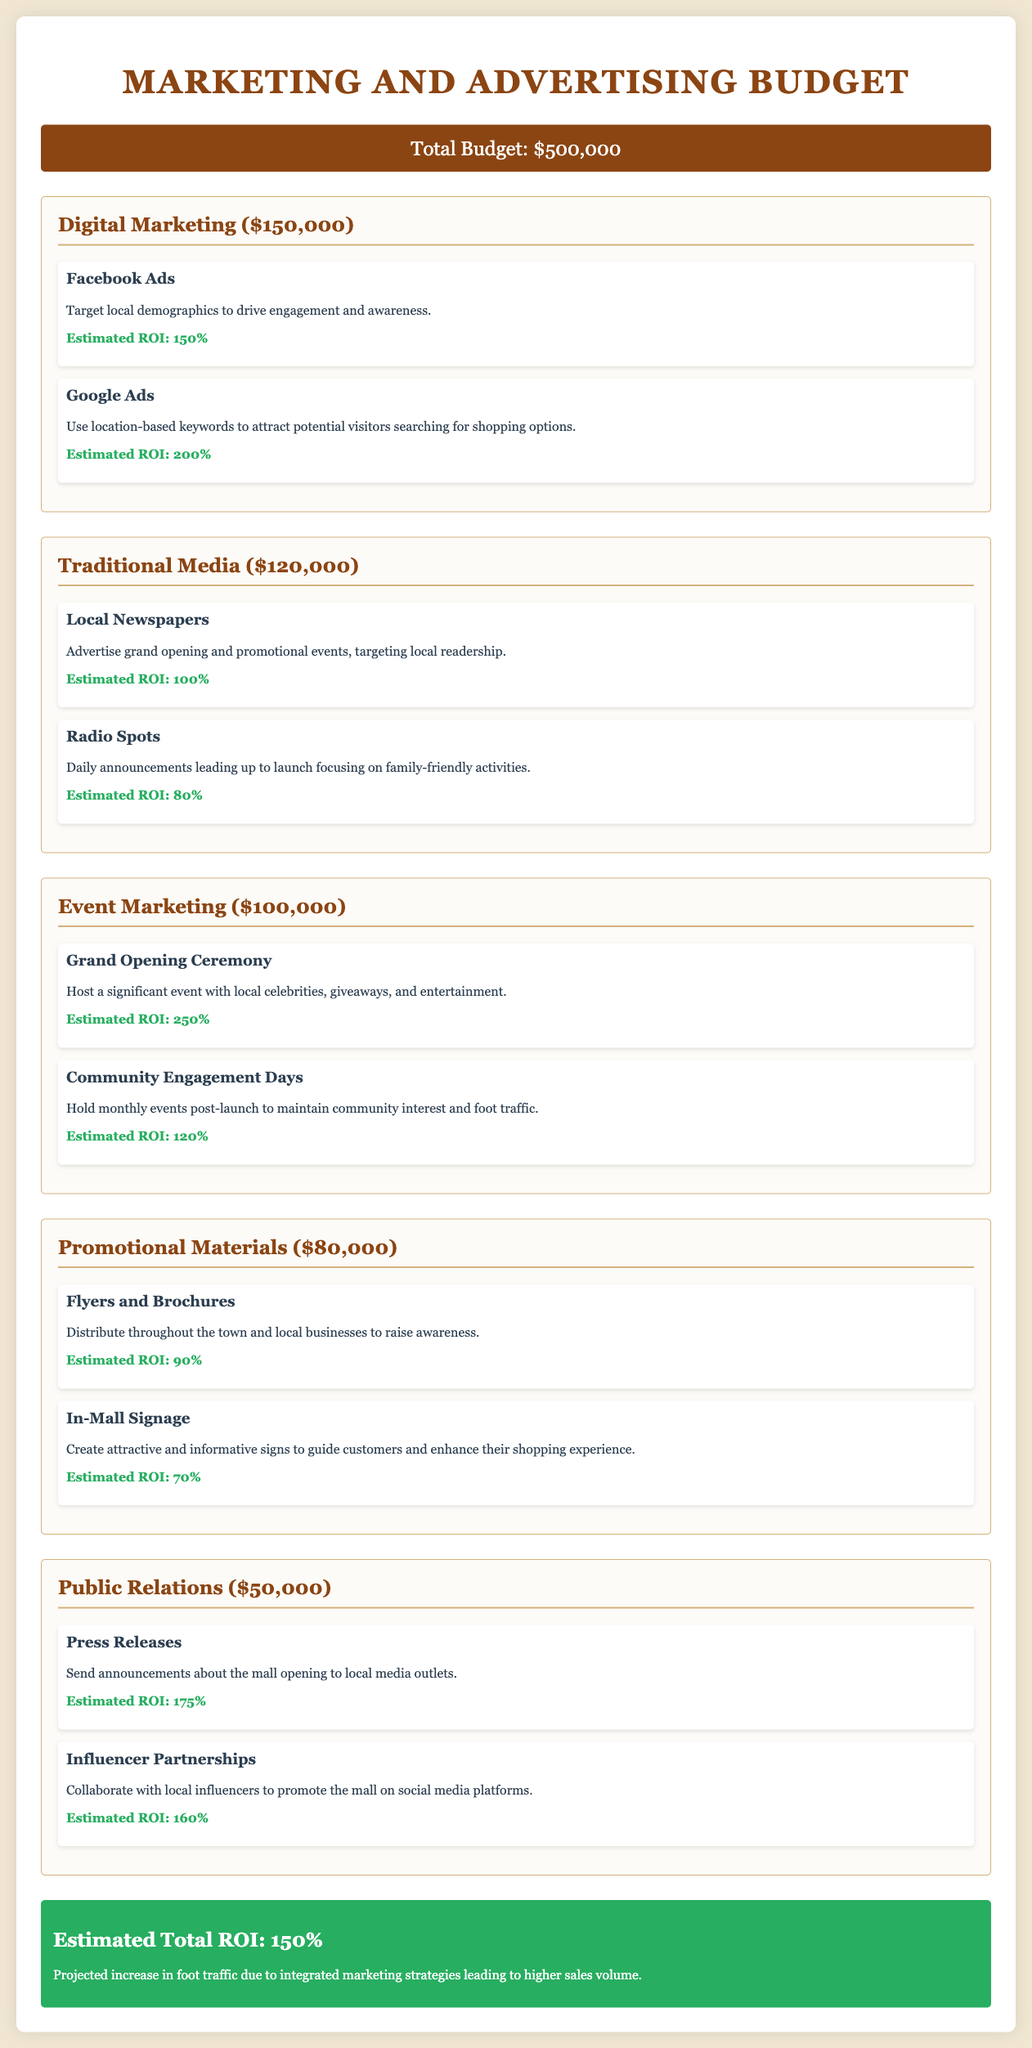what is the total budget? The total budget is clearly stated in the document at the top section under Total Budget.
Answer: $500,000 how much is allocated for Digital Marketing? The amount allocated for Digital Marketing is found in the section about the budget breakdown.
Answer: $150,000 what is the estimated ROI for Google Ads? The estimated ROI can be found in the Digital Marketing section under Google Ads strategy details.
Answer: 200% what promotional strategy involves local celebrities? This strategy is described in the Event Marketing section under the Grand Opening Ceremony.
Answer: Grand Opening Ceremony which media type has the highest estimated ROI? By comparing the ROIs given in each section, the highest ROI can be identified.
Answer: Grand Opening Ceremony (250%) what is the total estimated ROI for the marketing plan? The total estimated ROI is explained at the very bottom of the document.
Answer: 150% how much is set aside for Public Relations? The budget amount for Public Relations is specified in the corresponding section.
Answer: $50,000 which promotional materials are suggested for distribution? This information is found in the Promotional Materials section where the materials are listed.
Answer: Flyers and Brochures what is the estimated ROI for Press Releases? The ROI for Press Releases is stated in the Public Relations section.
Answer: 175% how much is allocated for Event Marketing? The amount designated for Event Marketing can be found in the budget breakdown in its respective section.
Answer: $100,000 